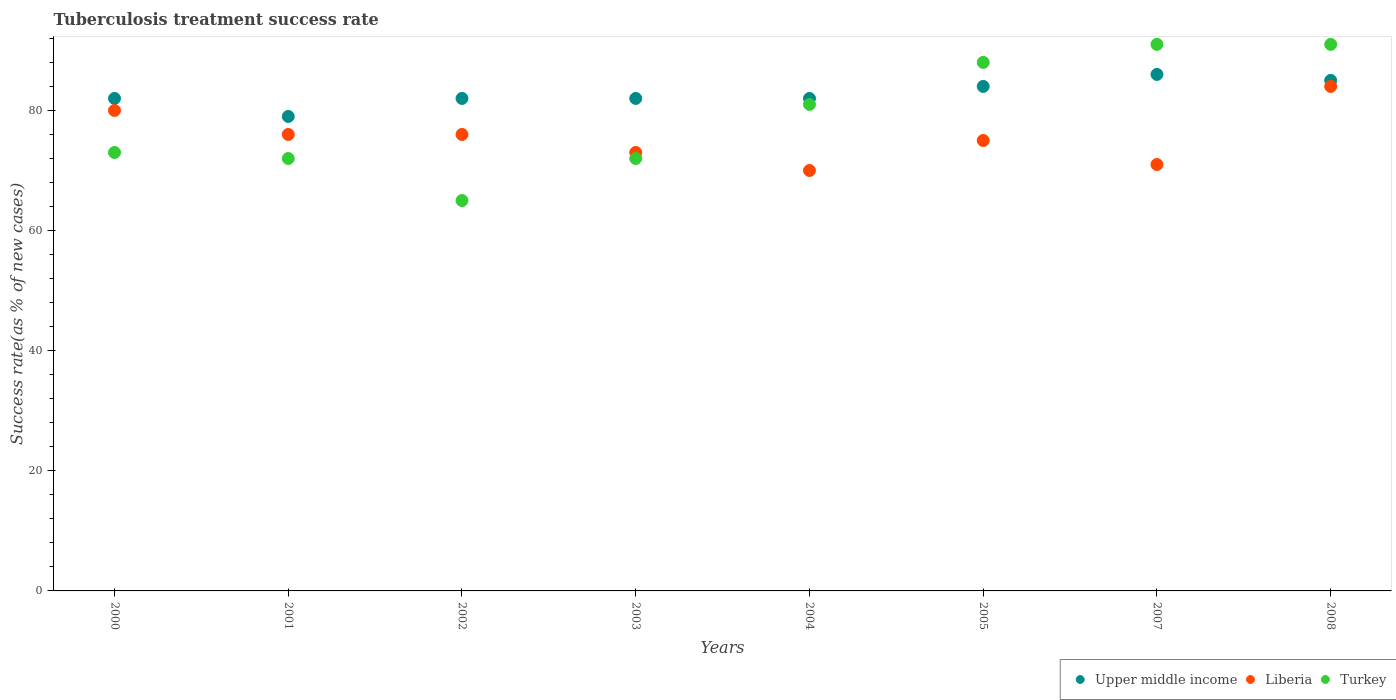Is the number of dotlines equal to the number of legend labels?
Give a very brief answer. Yes. Across all years, what is the maximum tuberculosis treatment success rate in Upper middle income?
Your response must be concise. 86. Across all years, what is the minimum tuberculosis treatment success rate in Upper middle income?
Provide a succinct answer. 79. In which year was the tuberculosis treatment success rate in Turkey minimum?
Offer a terse response. 2002. What is the total tuberculosis treatment success rate in Liberia in the graph?
Provide a short and direct response. 605. What is the difference between the tuberculosis treatment success rate in Upper middle income in 2000 and that in 2003?
Give a very brief answer. 0. What is the average tuberculosis treatment success rate in Turkey per year?
Ensure brevity in your answer.  79.12. In the year 2003, what is the difference between the tuberculosis treatment success rate in Upper middle income and tuberculosis treatment success rate in Turkey?
Your answer should be compact. 10. In how many years, is the tuberculosis treatment success rate in Turkey greater than 4 %?
Your answer should be compact. 8. What is the ratio of the tuberculosis treatment success rate in Liberia in 2000 to that in 2001?
Keep it short and to the point. 1.05. Is the tuberculosis treatment success rate in Upper middle income in 2001 less than that in 2004?
Your answer should be compact. Yes. What is the difference between the highest and the lowest tuberculosis treatment success rate in Upper middle income?
Provide a succinct answer. 7. Is the sum of the tuberculosis treatment success rate in Upper middle income in 2001 and 2003 greater than the maximum tuberculosis treatment success rate in Liberia across all years?
Your response must be concise. Yes. Is it the case that in every year, the sum of the tuberculosis treatment success rate in Turkey and tuberculosis treatment success rate in Upper middle income  is greater than the tuberculosis treatment success rate in Liberia?
Keep it short and to the point. Yes. Is the tuberculosis treatment success rate in Turkey strictly less than the tuberculosis treatment success rate in Liberia over the years?
Offer a terse response. No. What is the difference between two consecutive major ticks on the Y-axis?
Keep it short and to the point. 20. Are the values on the major ticks of Y-axis written in scientific E-notation?
Keep it short and to the point. No. Where does the legend appear in the graph?
Give a very brief answer. Bottom right. How many legend labels are there?
Your answer should be compact. 3. How are the legend labels stacked?
Give a very brief answer. Horizontal. What is the title of the graph?
Give a very brief answer. Tuberculosis treatment success rate. What is the label or title of the Y-axis?
Your answer should be very brief. Success rate(as % of new cases). What is the Success rate(as % of new cases) in Upper middle income in 2001?
Provide a succinct answer. 79. What is the Success rate(as % of new cases) of Turkey in 2002?
Your answer should be compact. 65. What is the Success rate(as % of new cases) of Upper middle income in 2003?
Provide a succinct answer. 82. What is the Success rate(as % of new cases) of Turkey in 2004?
Offer a very short reply. 81. What is the Success rate(as % of new cases) of Turkey in 2005?
Your answer should be compact. 88. What is the Success rate(as % of new cases) in Turkey in 2007?
Give a very brief answer. 91. What is the Success rate(as % of new cases) of Turkey in 2008?
Make the answer very short. 91. Across all years, what is the maximum Success rate(as % of new cases) of Liberia?
Ensure brevity in your answer.  84. Across all years, what is the maximum Success rate(as % of new cases) of Turkey?
Provide a succinct answer. 91. Across all years, what is the minimum Success rate(as % of new cases) of Upper middle income?
Keep it short and to the point. 79. Across all years, what is the minimum Success rate(as % of new cases) of Liberia?
Provide a short and direct response. 70. What is the total Success rate(as % of new cases) of Upper middle income in the graph?
Ensure brevity in your answer.  662. What is the total Success rate(as % of new cases) of Liberia in the graph?
Your answer should be compact. 605. What is the total Success rate(as % of new cases) in Turkey in the graph?
Your answer should be compact. 633. What is the difference between the Success rate(as % of new cases) of Turkey in 2000 and that in 2001?
Your answer should be very brief. 1. What is the difference between the Success rate(as % of new cases) in Upper middle income in 2000 and that in 2002?
Offer a terse response. 0. What is the difference between the Success rate(as % of new cases) in Liberia in 2000 and that in 2002?
Your response must be concise. 4. What is the difference between the Success rate(as % of new cases) in Turkey in 2000 and that in 2002?
Make the answer very short. 8. What is the difference between the Success rate(as % of new cases) of Upper middle income in 2000 and that in 2003?
Your answer should be compact. 0. What is the difference between the Success rate(as % of new cases) in Turkey in 2000 and that in 2004?
Your answer should be very brief. -8. What is the difference between the Success rate(as % of new cases) in Upper middle income in 2000 and that in 2005?
Offer a very short reply. -2. What is the difference between the Success rate(as % of new cases) of Turkey in 2000 and that in 2005?
Keep it short and to the point. -15. What is the difference between the Success rate(as % of new cases) of Upper middle income in 2000 and that in 2007?
Keep it short and to the point. -4. What is the difference between the Success rate(as % of new cases) of Liberia in 2000 and that in 2007?
Your answer should be very brief. 9. What is the difference between the Success rate(as % of new cases) in Turkey in 2000 and that in 2007?
Offer a terse response. -18. What is the difference between the Success rate(as % of new cases) in Turkey in 2000 and that in 2008?
Ensure brevity in your answer.  -18. What is the difference between the Success rate(as % of new cases) in Upper middle income in 2001 and that in 2002?
Offer a terse response. -3. What is the difference between the Success rate(as % of new cases) of Liberia in 2001 and that in 2002?
Offer a very short reply. 0. What is the difference between the Success rate(as % of new cases) in Upper middle income in 2001 and that in 2003?
Offer a terse response. -3. What is the difference between the Success rate(as % of new cases) of Upper middle income in 2001 and that in 2004?
Give a very brief answer. -3. What is the difference between the Success rate(as % of new cases) in Liberia in 2001 and that in 2004?
Make the answer very short. 6. What is the difference between the Success rate(as % of new cases) in Turkey in 2001 and that in 2004?
Your response must be concise. -9. What is the difference between the Success rate(as % of new cases) in Turkey in 2001 and that in 2005?
Your answer should be very brief. -16. What is the difference between the Success rate(as % of new cases) in Turkey in 2001 and that in 2007?
Provide a succinct answer. -19. What is the difference between the Success rate(as % of new cases) of Liberia in 2001 and that in 2008?
Keep it short and to the point. -8. What is the difference between the Success rate(as % of new cases) of Upper middle income in 2002 and that in 2003?
Make the answer very short. 0. What is the difference between the Success rate(as % of new cases) of Turkey in 2002 and that in 2003?
Make the answer very short. -7. What is the difference between the Success rate(as % of new cases) of Upper middle income in 2002 and that in 2004?
Your response must be concise. 0. What is the difference between the Success rate(as % of new cases) of Liberia in 2002 and that in 2004?
Your answer should be very brief. 6. What is the difference between the Success rate(as % of new cases) of Upper middle income in 2002 and that in 2005?
Give a very brief answer. -2. What is the difference between the Success rate(as % of new cases) in Turkey in 2002 and that in 2008?
Your answer should be compact. -26. What is the difference between the Success rate(as % of new cases) of Upper middle income in 2003 and that in 2004?
Your answer should be very brief. 0. What is the difference between the Success rate(as % of new cases) in Liberia in 2003 and that in 2004?
Make the answer very short. 3. What is the difference between the Success rate(as % of new cases) in Turkey in 2003 and that in 2004?
Your response must be concise. -9. What is the difference between the Success rate(as % of new cases) of Liberia in 2003 and that in 2005?
Keep it short and to the point. -2. What is the difference between the Success rate(as % of new cases) in Liberia in 2003 and that in 2007?
Ensure brevity in your answer.  2. What is the difference between the Success rate(as % of new cases) in Liberia in 2004 and that in 2005?
Make the answer very short. -5. What is the difference between the Success rate(as % of new cases) in Liberia in 2004 and that in 2007?
Give a very brief answer. -1. What is the difference between the Success rate(as % of new cases) in Turkey in 2004 and that in 2007?
Your answer should be very brief. -10. What is the difference between the Success rate(as % of new cases) of Liberia in 2004 and that in 2008?
Your response must be concise. -14. What is the difference between the Success rate(as % of new cases) of Upper middle income in 2005 and that in 2007?
Give a very brief answer. -2. What is the difference between the Success rate(as % of new cases) in Upper middle income in 2005 and that in 2008?
Provide a succinct answer. -1. What is the difference between the Success rate(as % of new cases) in Liberia in 2005 and that in 2008?
Make the answer very short. -9. What is the difference between the Success rate(as % of new cases) of Turkey in 2005 and that in 2008?
Provide a short and direct response. -3. What is the difference between the Success rate(as % of new cases) in Turkey in 2007 and that in 2008?
Ensure brevity in your answer.  0. What is the difference between the Success rate(as % of new cases) of Upper middle income in 2000 and the Success rate(as % of new cases) of Liberia in 2001?
Make the answer very short. 6. What is the difference between the Success rate(as % of new cases) of Upper middle income in 2000 and the Success rate(as % of new cases) of Turkey in 2001?
Your answer should be compact. 10. What is the difference between the Success rate(as % of new cases) in Upper middle income in 2000 and the Success rate(as % of new cases) in Liberia in 2002?
Ensure brevity in your answer.  6. What is the difference between the Success rate(as % of new cases) of Liberia in 2000 and the Success rate(as % of new cases) of Turkey in 2003?
Offer a very short reply. 8. What is the difference between the Success rate(as % of new cases) of Upper middle income in 2000 and the Success rate(as % of new cases) of Turkey in 2004?
Offer a very short reply. 1. What is the difference between the Success rate(as % of new cases) in Liberia in 2000 and the Success rate(as % of new cases) in Turkey in 2004?
Your response must be concise. -1. What is the difference between the Success rate(as % of new cases) of Upper middle income in 2000 and the Success rate(as % of new cases) of Liberia in 2007?
Your response must be concise. 11. What is the difference between the Success rate(as % of new cases) of Liberia in 2000 and the Success rate(as % of new cases) of Turkey in 2007?
Keep it short and to the point. -11. What is the difference between the Success rate(as % of new cases) of Upper middle income in 2000 and the Success rate(as % of new cases) of Liberia in 2008?
Your answer should be very brief. -2. What is the difference between the Success rate(as % of new cases) of Liberia in 2001 and the Success rate(as % of new cases) of Turkey in 2002?
Give a very brief answer. 11. What is the difference between the Success rate(as % of new cases) in Upper middle income in 2001 and the Success rate(as % of new cases) in Turkey in 2003?
Ensure brevity in your answer.  7. What is the difference between the Success rate(as % of new cases) of Liberia in 2001 and the Success rate(as % of new cases) of Turkey in 2003?
Give a very brief answer. 4. What is the difference between the Success rate(as % of new cases) in Upper middle income in 2001 and the Success rate(as % of new cases) in Liberia in 2004?
Provide a succinct answer. 9. What is the difference between the Success rate(as % of new cases) of Upper middle income in 2001 and the Success rate(as % of new cases) of Turkey in 2004?
Make the answer very short. -2. What is the difference between the Success rate(as % of new cases) of Upper middle income in 2001 and the Success rate(as % of new cases) of Turkey in 2005?
Offer a very short reply. -9. What is the difference between the Success rate(as % of new cases) in Liberia in 2001 and the Success rate(as % of new cases) in Turkey in 2005?
Offer a very short reply. -12. What is the difference between the Success rate(as % of new cases) of Upper middle income in 2001 and the Success rate(as % of new cases) of Turkey in 2007?
Ensure brevity in your answer.  -12. What is the difference between the Success rate(as % of new cases) in Liberia in 2001 and the Success rate(as % of new cases) in Turkey in 2007?
Provide a short and direct response. -15. What is the difference between the Success rate(as % of new cases) of Upper middle income in 2001 and the Success rate(as % of new cases) of Turkey in 2008?
Provide a short and direct response. -12. What is the difference between the Success rate(as % of new cases) in Liberia in 2001 and the Success rate(as % of new cases) in Turkey in 2008?
Your answer should be compact. -15. What is the difference between the Success rate(as % of new cases) of Upper middle income in 2002 and the Success rate(as % of new cases) of Liberia in 2004?
Your response must be concise. 12. What is the difference between the Success rate(as % of new cases) in Upper middle income in 2002 and the Success rate(as % of new cases) in Turkey in 2007?
Ensure brevity in your answer.  -9. What is the difference between the Success rate(as % of new cases) in Upper middle income in 2002 and the Success rate(as % of new cases) in Liberia in 2008?
Provide a short and direct response. -2. What is the difference between the Success rate(as % of new cases) of Upper middle income in 2002 and the Success rate(as % of new cases) of Turkey in 2008?
Your answer should be compact. -9. What is the difference between the Success rate(as % of new cases) in Upper middle income in 2003 and the Success rate(as % of new cases) in Liberia in 2004?
Keep it short and to the point. 12. What is the difference between the Success rate(as % of new cases) of Liberia in 2003 and the Success rate(as % of new cases) of Turkey in 2004?
Make the answer very short. -8. What is the difference between the Success rate(as % of new cases) in Upper middle income in 2003 and the Success rate(as % of new cases) in Liberia in 2005?
Your answer should be very brief. 7. What is the difference between the Success rate(as % of new cases) in Upper middle income in 2003 and the Success rate(as % of new cases) in Turkey in 2005?
Offer a very short reply. -6. What is the difference between the Success rate(as % of new cases) of Liberia in 2003 and the Success rate(as % of new cases) of Turkey in 2005?
Your answer should be compact. -15. What is the difference between the Success rate(as % of new cases) in Upper middle income in 2003 and the Success rate(as % of new cases) in Liberia in 2007?
Make the answer very short. 11. What is the difference between the Success rate(as % of new cases) in Liberia in 2003 and the Success rate(as % of new cases) in Turkey in 2007?
Provide a short and direct response. -18. What is the difference between the Success rate(as % of new cases) of Upper middle income in 2003 and the Success rate(as % of new cases) of Liberia in 2008?
Your answer should be very brief. -2. What is the difference between the Success rate(as % of new cases) of Upper middle income in 2003 and the Success rate(as % of new cases) of Turkey in 2008?
Make the answer very short. -9. What is the difference between the Success rate(as % of new cases) in Upper middle income in 2004 and the Success rate(as % of new cases) in Liberia in 2005?
Provide a succinct answer. 7. What is the difference between the Success rate(as % of new cases) of Upper middle income in 2004 and the Success rate(as % of new cases) of Turkey in 2005?
Your answer should be very brief. -6. What is the difference between the Success rate(as % of new cases) in Upper middle income in 2004 and the Success rate(as % of new cases) in Turkey in 2008?
Your answer should be compact. -9. What is the difference between the Success rate(as % of new cases) in Liberia in 2004 and the Success rate(as % of new cases) in Turkey in 2008?
Ensure brevity in your answer.  -21. What is the difference between the Success rate(as % of new cases) of Liberia in 2005 and the Success rate(as % of new cases) of Turkey in 2007?
Offer a terse response. -16. What is the difference between the Success rate(as % of new cases) of Upper middle income in 2005 and the Success rate(as % of new cases) of Liberia in 2008?
Your answer should be compact. 0. What is the difference between the Success rate(as % of new cases) of Upper middle income in 2005 and the Success rate(as % of new cases) of Turkey in 2008?
Give a very brief answer. -7. What is the difference between the Success rate(as % of new cases) in Liberia in 2005 and the Success rate(as % of new cases) in Turkey in 2008?
Keep it short and to the point. -16. What is the difference between the Success rate(as % of new cases) of Upper middle income in 2007 and the Success rate(as % of new cases) of Turkey in 2008?
Provide a short and direct response. -5. What is the average Success rate(as % of new cases) of Upper middle income per year?
Give a very brief answer. 82.75. What is the average Success rate(as % of new cases) of Liberia per year?
Your answer should be very brief. 75.62. What is the average Success rate(as % of new cases) of Turkey per year?
Ensure brevity in your answer.  79.12. In the year 2001, what is the difference between the Success rate(as % of new cases) in Liberia and Success rate(as % of new cases) in Turkey?
Make the answer very short. 4. In the year 2002, what is the difference between the Success rate(as % of new cases) of Liberia and Success rate(as % of new cases) of Turkey?
Offer a terse response. 11. In the year 2003, what is the difference between the Success rate(as % of new cases) in Upper middle income and Success rate(as % of new cases) in Liberia?
Give a very brief answer. 9. In the year 2003, what is the difference between the Success rate(as % of new cases) in Liberia and Success rate(as % of new cases) in Turkey?
Make the answer very short. 1. In the year 2004, what is the difference between the Success rate(as % of new cases) of Liberia and Success rate(as % of new cases) of Turkey?
Offer a very short reply. -11. In the year 2005, what is the difference between the Success rate(as % of new cases) in Upper middle income and Success rate(as % of new cases) in Liberia?
Your answer should be compact. 9. In the year 2007, what is the difference between the Success rate(as % of new cases) of Upper middle income and Success rate(as % of new cases) of Liberia?
Provide a succinct answer. 15. In the year 2008, what is the difference between the Success rate(as % of new cases) of Upper middle income and Success rate(as % of new cases) of Liberia?
Offer a terse response. 1. In the year 2008, what is the difference between the Success rate(as % of new cases) in Liberia and Success rate(as % of new cases) in Turkey?
Ensure brevity in your answer.  -7. What is the ratio of the Success rate(as % of new cases) of Upper middle income in 2000 to that in 2001?
Give a very brief answer. 1.04. What is the ratio of the Success rate(as % of new cases) of Liberia in 2000 to that in 2001?
Your response must be concise. 1.05. What is the ratio of the Success rate(as % of new cases) in Turkey in 2000 to that in 2001?
Provide a succinct answer. 1.01. What is the ratio of the Success rate(as % of new cases) of Upper middle income in 2000 to that in 2002?
Your answer should be compact. 1. What is the ratio of the Success rate(as % of new cases) in Liberia in 2000 to that in 2002?
Your answer should be very brief. 1.05. What is the ratio of the Success rate(as % of new cases) of Turkey in 2000 to that in 2002?
Your response must be concise. 1.12. What is the ratio of the Success rate(as % of new cases) in Liberia in 2000 to that in 2003?
Provide a succinct answer. 1.1. What is the ratio of the Success rate(as % of new cases) in Turkey in 2000 to that in 2003?
Your answer should be very brief. 1.01. What is the ratio of the Success rate(as % of new cases) in Liberia in 2000 to that in 2004?
Ensure brevity in your answer.  1.14. What is the ratio of the Success rate(as % of new cases) in Turkey in 2000 to that in 2004?
Your answer should be very brief. 0.9. What is the ratio of the Success rate(as % of new cases) in Upper middle income in 2000 to that in 2005?
Make the answer very short. 0.98. What is the ratio of the Success rate(as % of new cases) in Liberia in 2000 to that in 2005?
Keep it short and to the point. 1.07. What is the ratio of the Success rate(as % of new cases) in Turkey in 2000 to that in 2005?
Give a very brief answer. 0.83. What is the ratio of the Success rate(as % of new cases) in Upper middle income in 2000 to that in 2007?
Your answer should be very brief. 0.95. What is the ratio of the Success rate(as % of new cases) in Liberia in 2000 to that in 2007?
Give a very brief answer. 1.13. What is the ratio of the Success rate(as % of new cases) in Turkey in 2000 to that in 2007?
Offer a very short reply. 0.8. What is the ratio of the Success rate(as % of new cases) in Upper middle income in 2000 to that in 2008?
Your response must be concise. 0.96. What is the ratio of the Success rate(as % of new cases) in Turkey in 2000 to that in 2008?
Keep it short and to the point. 0.8. What is the ratio of the Success rate(as % of new cases) in Upper middle income in 2001 to that in 2002?
Offer a very short reply. 0.96. What is the ratio of the Success rate(as % of new cases) in Turkey in 2001 to that in 2002?
Give a very brief answer. 1.11. What is the ratio of the Success rate(as % of new cases) of Upper middle income in 2001 to that in 2003?
Ensure brevity in your answer.  0.96. What is the ratio of the Success rate(as % of new cases) of Liberia in 2001 to that in 2003?
Ensure brevity in your answer.  1.04. What is the ratio of the Success rate(as % of new cases) of Upper middle income in 2001 to that in 2004?
Ensure brevity in your answer.  0.96. What is the ratio of the Success rate(as % of new cases) in Liberia in 2001 to that in 2004?
Give a very brief answer. 1.09. What is the ratio of the Success rate(as % of new cases) in Upper middle income in 2001 to that in 2005?
Provide a succinct answer. 0.94. What is the ratio of the Success rate(as % of new cases) of Liberia in 2001 to that in 2005?
Your answer should be very brief. 1.01. What is the ratio of the Success rate(as % of new cases) of Turkey in 2001 to that in 2005?
Your answer should be very brief. 0.82. What is the ratio of the Success rate(as % of new cases) in Upper middle income in 2001 to that in 2007?
Ensure brevity in your answer.  0.92. What is the ratio of the Success rate(as % of new cases) in Liberia in 2001 to that in 2007?
Keep it short and to the point. 1.07. What is the ratio of the Success rate(as % of new cases) in Turkey in 2001 to that in 2007?
Your answer should be compact. 0.79. What is the ratio of the Success rate(as % of new cases) in Upper middle income in 2001 to that in 2008?
Offer a terse response. 0.93. What is the ratio of the Success rate(as % of new cases) in Liberia in 2001 to that in 2008?
Provide a succinct answer. 0.9. What is the ratio of the Success rate(as % of new cases) of Turkey in 2001 to that in 2008?
Provide a succinct answer. 0.79. What is the ratio of the Success rate(as % of new cases) in Liberia in 2002 to that in 2003?
Keep it short and to the point. 1.04. What is the ratio of the Success rate(as % of new cases) in Turkey in 2002 to that in 2003?
Offer a terse response. 0.9. What is the ratio of the Success rate(as % of new cases) of Upper middle income in 2002 to that in 2004?
Ensure brevity in your answer.  1. What is the ratio of the Success rate(as % of new cases) in Liberia in 2002 to that in 2004?
Ensure brevity in your answer.  1.09. What is the ratio of the Success rate(as % of new cases) of Turkey in 2002 to that in 2004?
Provide a succinct answer. 0.8. What is the ratio of the Success rate(as % of new cases) of Upper middle income in 2002 to that in 2005?
Give a very brief answer. 0.98. What is the ratio of the Success rate(as % of new cases) in Liberia in 2002 to that in 2005?
Give a very brief answer. 1.01. What is the ratio of the Success rate(as % of new cases) in Turkey in 2002 to that in 2005?
Offer a terse response. 0.74. What is the ratio of the Success rate(as % of new cases) in Upper middle income in 2002 to that in 2007?
Give a very brief answer. 0.95. What is the ratio of the Success rate(as % of new cases) in Liberia in 2002 to that in 2007?
Make the answer very short. 1.07. What is the ratio of the Success rate(as % of new cases) of Upper middle income in 2002 to that in 2008?
Your response must be concise. 0.96. What is the ratio of the Success rate(as % of new cases) in Liberia in 2002 to that in 2008?
Your response must be concise. 0.9. What is the ratio of the Success rate(as % of new cases) in Turkey in 2002 to that in 2008?
Keep it short and to the point. 0.71. What is the ratio of the Success rate(as % of new cases) in Liberia in 2003 to that in 2004?
Offer a very short reply. 1.04. What is the ratio of the Success rate(as % of new cases) in Turkey in 2003 to that in 2004?
Provide a short and direct response. 0.89. What is the ratio of the Success rate(as % of new cases) in Upper middle income in 2003 to that in 2005?
Keep it short and to the point. 0.98. What is the ratio of the Success rate(as % of new cases) in Liberia in 2003 to that in 2005?
Offer a terse response. 0.97. What is the ratio of the Success rate(as % of new cases) of Turkey in 2003 to that in 2005?
Provide a short and direct response. 0.82. What is the ratio of the Success rate(as % of new cases) in Upper middle income in 2003 to that in 2007?
Ensure brevity in your answer.  0.95. What is the ratio of the Success rate(as % of new cases) of Liberia in 2003 to that in 2007?
Make the answer very short. 1.03. What is the ratio of the Success rate(as % of new cases) of Turkey in 2003 to that in 2007?
Offer a terse response. 0.79. What is the ratio of the Success rate(as % of new cases) in Upper middle income in 2003 to that in 2008?
Your answer should be compact. 0.96. What is the ratio of the Success rate(as % of new cases) of Liberia in 2003 to that in 2008?
Make the answer very short. 0.87. What is the ratio of the Success rate(as % of new cases) in Turkey in 2003 to that in 2008?
Give a very brief answer. 0.79. What is the ratio of the Success rate(as % of new cases) in Upper middle income in 2004 to that in 2005?
Keep it short and to the point. 0.98. What is the ratio of the Success rate(as % of new cases) of Turkey in 2004 to that in 2005?
Give a very brief answer. 0.92. What is the ratio of the Success rate(as % of new cases) in Upper middle income in 2004 to that in 2007?
Make the answer very short. 0.95. What is the ratio of the Success rate(as % of new cases) in Liberia in 2004 to that in 2007?
Offer a very short reply. 0.99. What is the ratio of the Success rate(as % of new cases) in Turkey in 2004 to that in 2007?
Give a very brief answer. 0.89. What is the ratio of the Success rate(as % of new cases) in Upper middle income in 2004 to that in 2008?
Offer a very short reply. 0.96. What is the ratio of the Success rate(as % of new cases) in Liberia in 2004 to that in 2008?
Your answer should be compact. 0.83. What is the ratio of the Success rate(as % of new cases) in Turkey in 2004 to that in 2008?
Your answer should be compact. 0.89. What is the ratio of the Success rate(as % of new cases) of Upper middle income in 2005 to that in 2007?
Your answer should be very brief. 0.98. What is the ratio of the Success rate(as % of new cases) in Liberia in 2005 to that in 2007?
Offer a very short reply. 1.06. What is the ratio of the Success rate(as % of new cases) in Turkey in 2005 to that in 2007?
Ensure brevity in your answer.  0.97. What is the ratio of the Success rate(as % of new cases) of Liberia in 2005 to that in 2008?
Ensure brevity in your answer.  0.89. What is the ratio of the Success rate(as % of new cases) of Upper middle income in 2007 to that in 2008?
Your answer should be very brief. 1.01. What is the ratio of the Success rate(as % of new cases) in Liberia in 2007 to that in 2008?
Keep it short and to the point. 0.85. What is the difference between the highest and the second highest Success rate(as % of new cases) in Upper middle income?
Your response must be concise. 1. What is the difference between the highest and the second highest Success rate(as % of new cases) of Liberia?
Give a very brief answer. 4. What is the difference between the highest and the lowest Success rate(as % of new cases) in Liberia?
Your answer should be very brief. 14. 